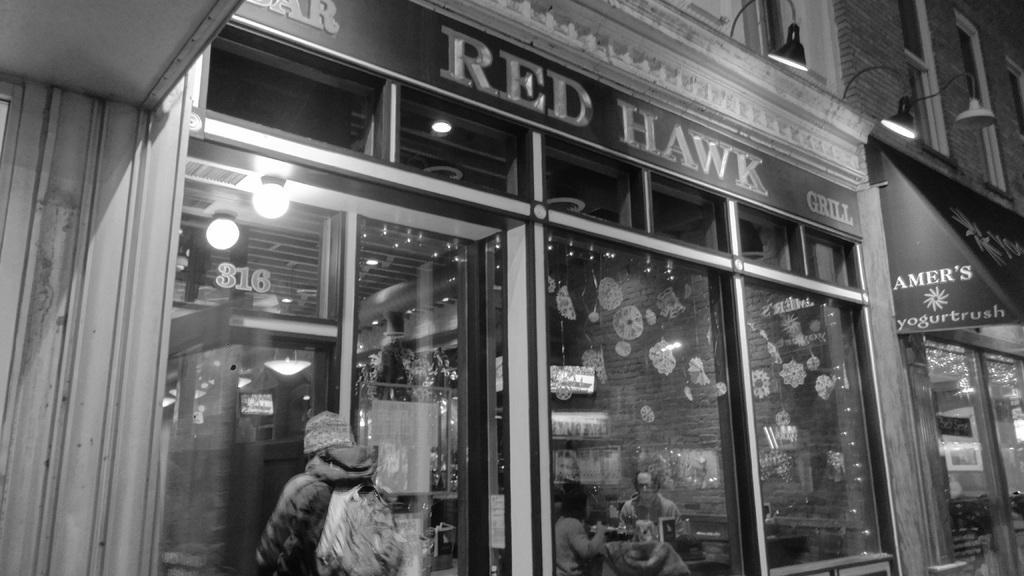How would you summarize this image in a sentence or two? In front of the image there are boards with some text on it on the buildings. There are glass doors through which we can see a person standing and there are two people sitting on the chairs. There are some objects on the table. In the background of the image there are some decorative items on the wall. On top of the image there are lights. 